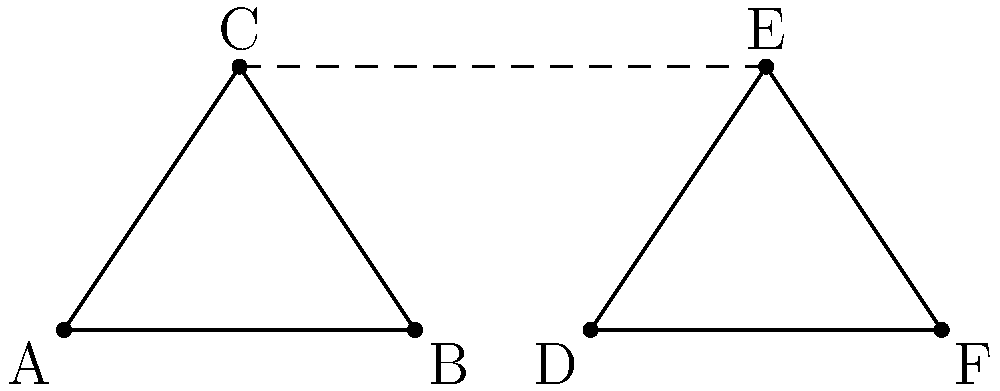A local pet adoption center is designing a new logo featuring two triangles. In the image above, triangle ABC represents a dog's face, and triangle DEF represents a cat's face. The designer wants to ensure these triangles are congruent. Which pair of corresponding sides would you need to measure to confirm the triangles are congruent, given that $\angle BAC = \angle EDF$ and $\angle BCA = \angle DEF$? Let's approach this step-by-step:

1. We are given that $\angle BAC = \angle EDF$ and $\angle BCA = \angle DEF$. This means we already have two pairs of congruent angles.

2. To prove two triangles are congruent, we can use the ASA (Angle-Side-Angle) congruence criterion. This states that if two angles and the included side of one triangle are congruent to two angles and the included side of another triangle, then the triangles are congruent.

3. We already have two pairs of congruent angles. We now need to find the included side between these angles in both triangles.

4. In triangle ABC, the side between $\angle BAC$ and $\angle BCA$ is BC.
   In triangle DEF, the side between $\angle EDF$ and $\angle DEF$ is EF.

5. Therefore, if we measure and compare BC and EF, and they are equal, we can conclude that the triangles are congruent using the ASA criterion.
Answer: BC and EF 